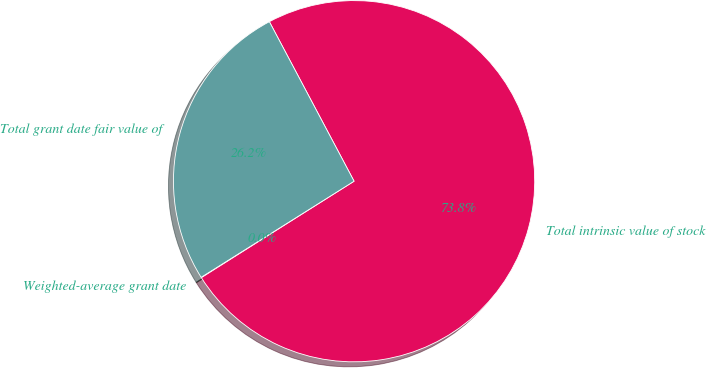Convert chart to OTSL. <chart><loc_0><loc_0><loc_500><loc_500><pie_chart><fcel>Weighted-average grant date<fcel>Total intrinsic value of stock<fcel>Total grant date fair value of<nl><fcel>0.04%<fcel>73.8%<fcel>26.16%<nl></chart> 